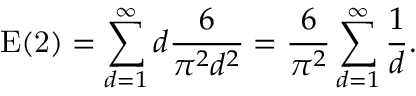Convert formula to latex. <formula><loc_0><loc_0><loc_500><loc_500>E ( 2 ) = \sum _ { d = 1 } ^ { \infty } d { \frac { 6 } { \pi ^ { 2 } d ^ { 2 } } } = { \frac { 6 } { \pi ^ { 2 } } } \sum _ { d = 1 } ^ { \infty } { \frac { 1 } { d } } .</formula> 